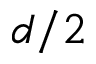<formula> <loc_0><loc_0><loc_500><loc_500>d / 2</formula> 